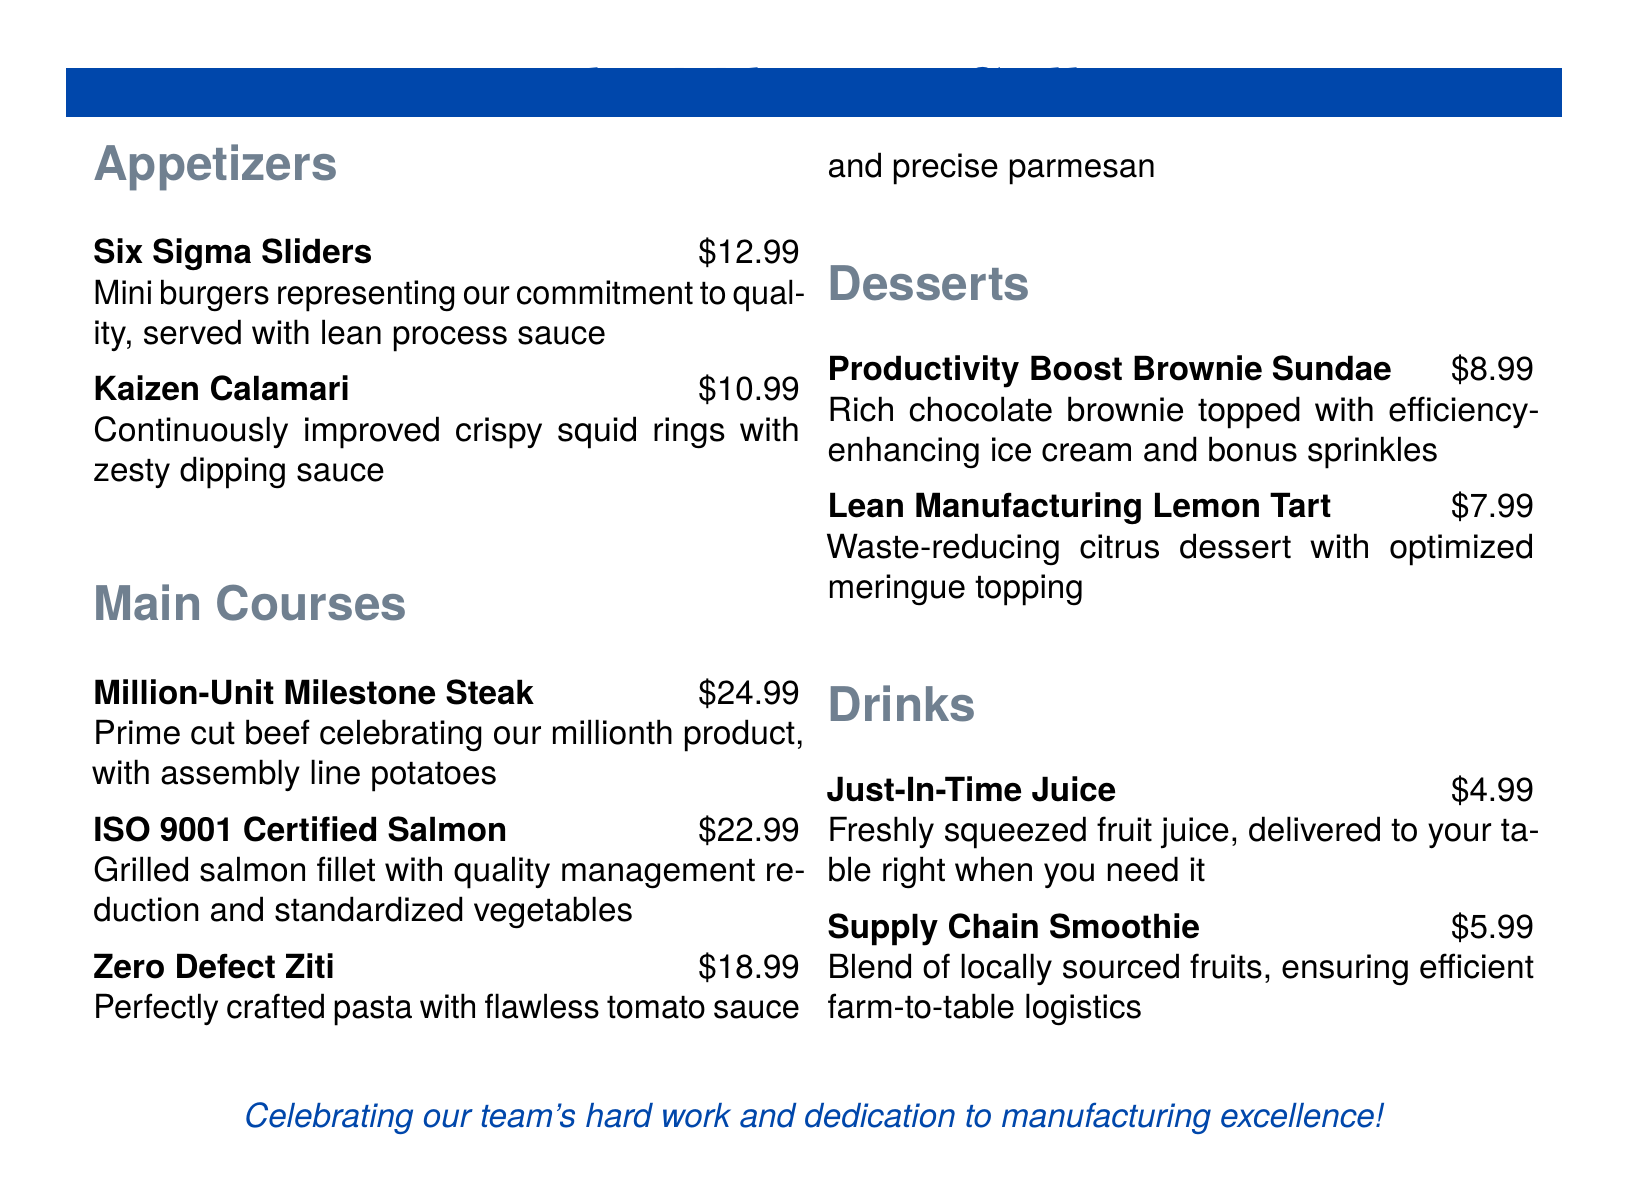what is the price of Six Sigma Sliders? The price for the Six Sigma Sliders is indicated in the menu, which is $12.99.
Answer: $12.99 how many appetizers are listed on the menu? The menu lists two appetizers: Six Sigma Sliders and Kaizen Calamari.
Answer: 2 what type of dessert is the Lean Manufacturing Lemon Tart? The Lean Manufacturing Lemon Tart is described as a citrus dessert.
Answer: citrus dessert which main course is named after a standard certification? The main course named after a standard certification is the ISO 9001 Certified Salmon.
Answer: ISO 9001 Certified Salmon what is the theme of the menu? The theme of the menu is centered around manufacturing milestones and company successes.
Answer: manufacturing milestones what beverage is freshly squeezed? The beverage that is freshly squeezed is Just-In-Time Juice.
Answer: Just-In-Time Juice how much does the Zero Defect Ziti cost? The cost for the Zero Defect Ziti is stated in the menu as $18.99.
Answer: $18.99 which dessert is associated with a productivity boost? The dessert associated with a productivity boost is the Productivity Boost Brownie Sundae.
Answer: Productivity Boost Brownie Sundae 